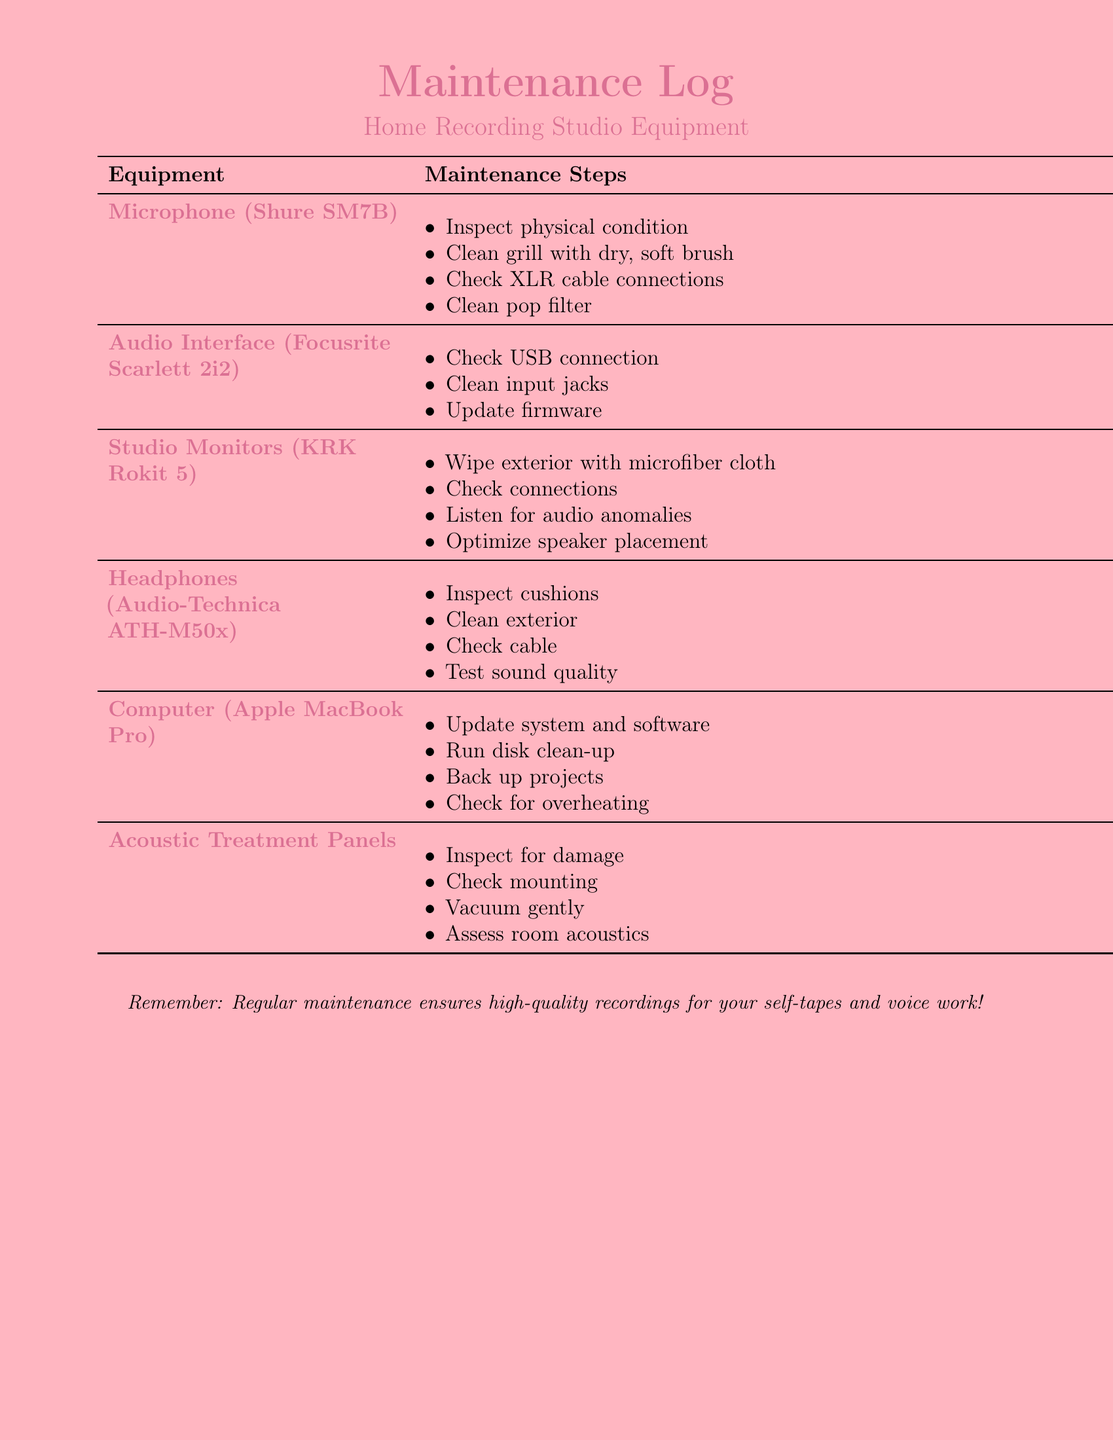What is the first equipment listed? The first equipment listed in the maintenance log is the microphone, specifically the Shure SM7B.
Answer: Shure SM7B How many maintenance steps are there for the Audio Interface? The maintenance steps for the Audio Interface consist of three specific actions mentioned in the document.
Answer: 3 What is the primary cleaning tool recommended for the microphone? The log suggests using a dry, soft brush to clean the grill of the microphone.
Answer: Dry, soft brush Which equipment requires checking for overheating? The Computer (Apple MacBook Pro) is the equipment that requires checking for overheating as part of its maintenance.
Answer: Computer (Apple MacBook Pro) What should be done to the Studio Monitors’ exterior? The maintenance log indicates that the exterior of the Studio Monitors should be wiped with a microfiber cloth.
Answer: Wipe with microfiber cloth Why is regular maintenance important according to the log? The document specifies that regular maintenance ensures high-quality recordings for self-tapes and voice work.
Answer: High-quality recordings What equipment needs firmware updates? The maintenance log states that the Audio Interface (Focusrite Scarlett 2i2) requires firmware updates as part of its maintenance steps.
Answer: Audio Interface (Focusrite Scarlett 2i2) How should the Acoustic Treatment Panels be cleaned? The log advises vacuuming the Acoustic Treatment Panels gently to clean them.
Answer: Vacuum gently 